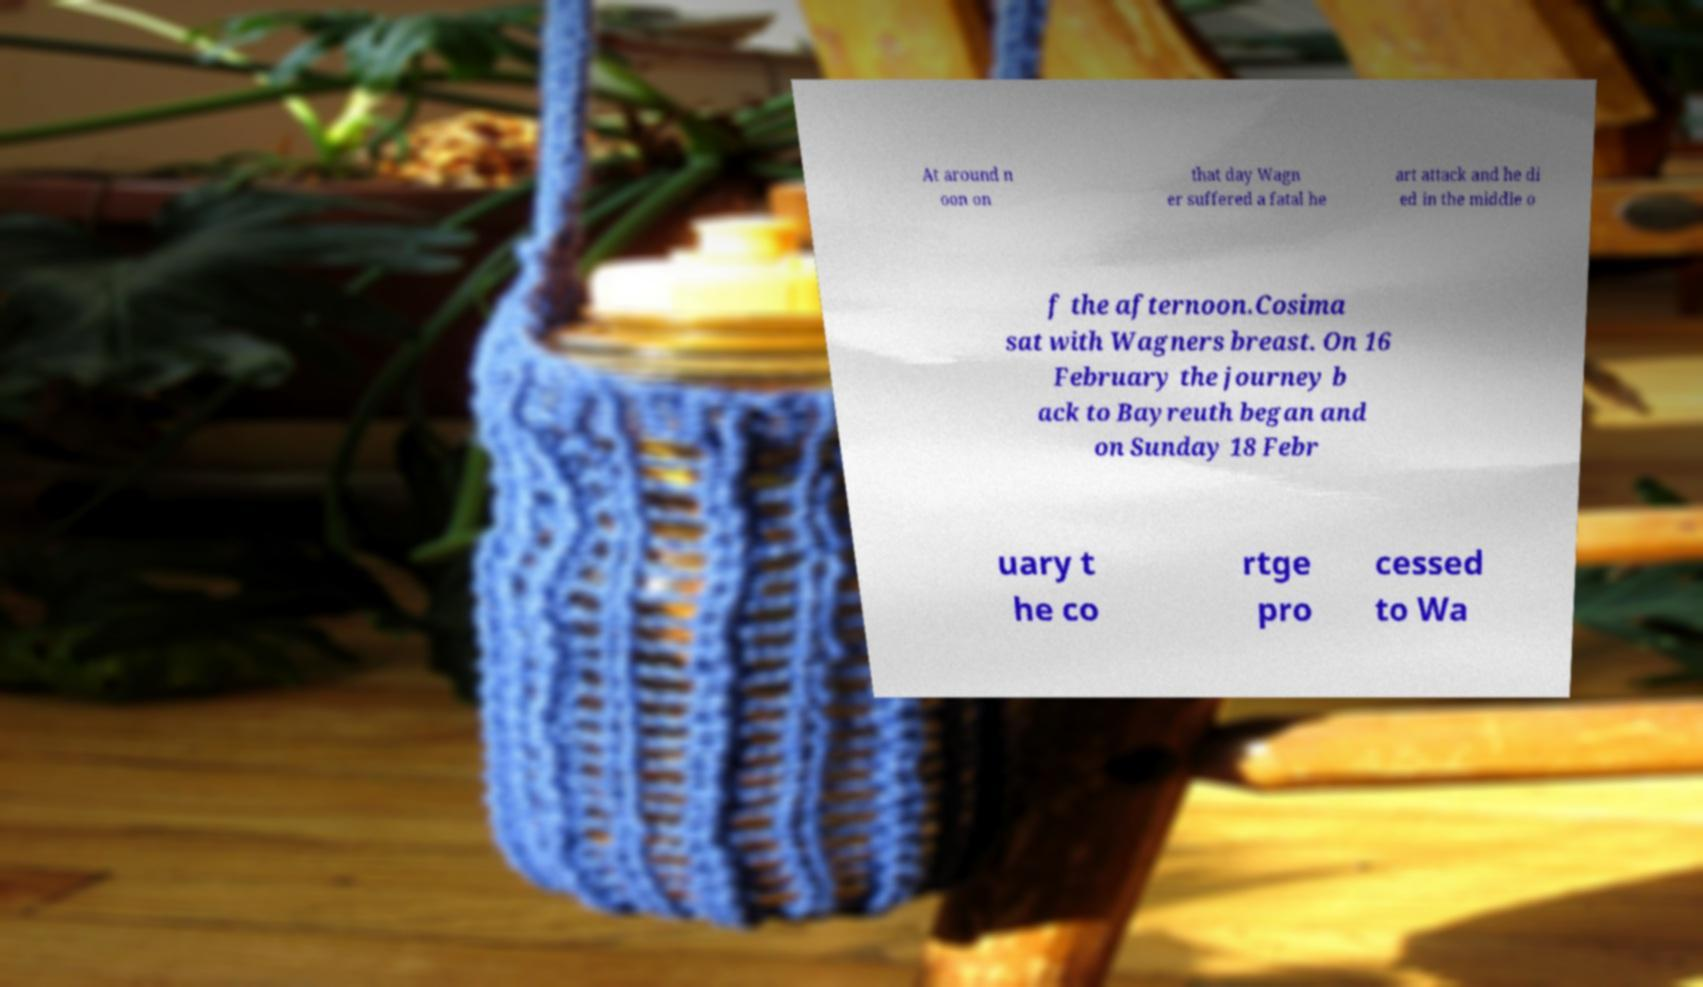Can you accurately transcribe the text from the provided image for me? At around n oon on that day Wagn er suffered a fatal he art attack and he di ed in the middle o f the afternoon.Cosima sat with Wagners breast. On 16 February the journey b ack to Bayreuth began and on Sunday 18 Febr uary t he co rtge pro cessed to Wa 